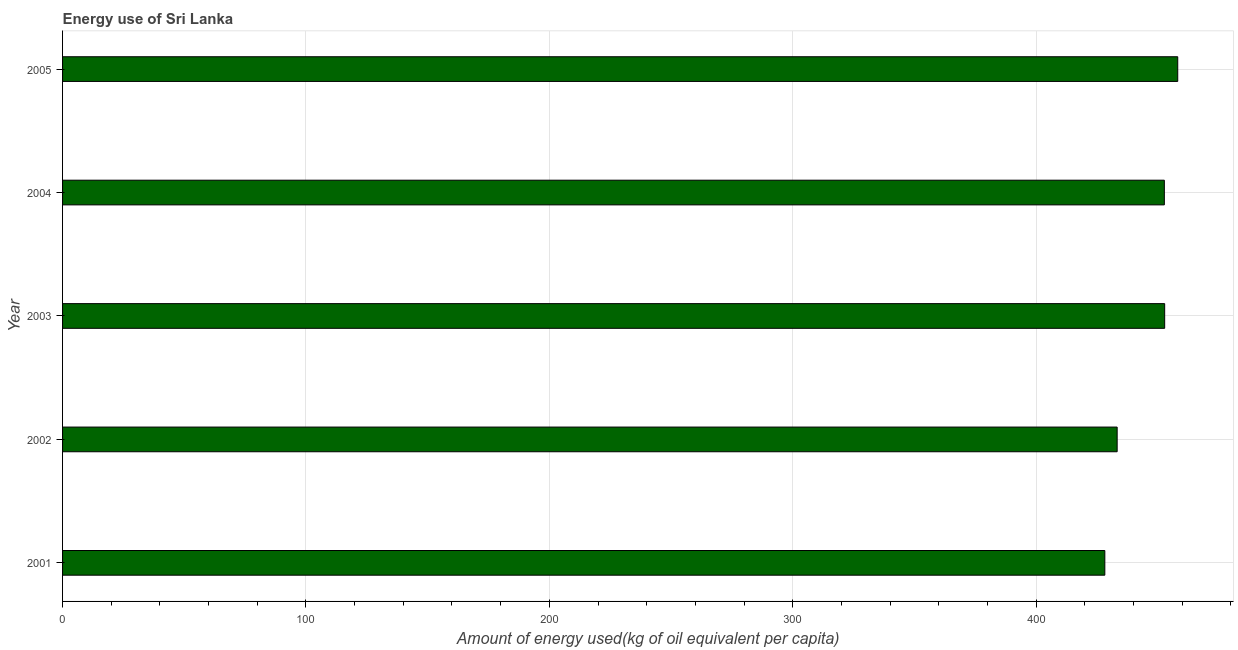What is the title of the graph?
Give a very brief answer. Energy use of Sri Lanka. What is the label or title of the X-axis?
Ensure brevity in your answer.  Amount of energy used(kg of oil equivalent per capita). What is the label or title of the Y-axis?
Offer a very short reply. Year. What is the amount of energy used in 2001?
Keep it short and to the point. 428.23. Across all years, what is the maximum amount of energy used?
Offer a terse response. 458.19. Across all years, what is the minimum amount of energy used?
Provide a succinct answer. 428.23. In which year was the amount of energy used maximum?
Provide a succinct answer. 2005. In which year was the amount of energy used minimum?
Provide a short and direct response. 2001. What is the sum of the amount of energy used?
Your answer should be very brief. 2225.23. What is the difference between the amount of energy used in 2001 and 2005?
Your answer should be very brief. -29.96. What is the average amount of energy used per year?
Provide a succinct answer. 445.05. What is the median amount of energy used?
Make the answer very short. 452.69. In how many years, is the amount of energy used greater than 240 kg?
Make the answer very short. 5. Do a majority of the years between 2001 and 2005 (inclusive) have amount of energy used greater than 100 kg?
Make the answer very short. Yes. What is the ratio of the amount of energy used in 2004 to that in 2005?
Your answer should be compact. 0.99. Is the amount of energy used in 2003 less than that in 2004?
Offer a terse response. No. Is the difference between the amount of energy used in 2002 and 2003 greater than the difference between any two years?
Provide a short and direct response. No. What is the difference between the highest and the second highest amount of energy used?
Give a very brief answer. 5.37. Is the sum of the amount of energy used in 2002 and 2005 greater than the maximum amount of energy used across all years?
Provide a short and direct response. Yes. What is the difference between the highest and the lowest amount of energy used?
Make the answer very short. 29.96. In how many years, is the amount of energy used greater than the average amount of energy used taken over all years?
Provide a short and direct response. 3. What is the Amount of energy used(kg of oil equivalent per capita) of 2001?
Offer a very short reply. 428.23. What is the Amount of energy used(kg of oil equivalent per capita) of 2002?
Offer a very short reply. 433.3. What is the Amount of energy used(kg of oil equivalent per capita) in 2003?
Make the answer very short. 452.82. What is the Amount of energy used(kg of oil equivalent per capita) in 2004?
Provide a short and direct response. 452.69. What is the Amount of energy used(kg of oil equivalent per capita) in 2005?
Your response must be concise. 458.19. What is the difference between the Amount of energy used(kg of oil equivalent per capita) in 2001 and 2002?
Give a very brief answer. -5.07. What is the difference between the Amount of energy used(kg of oil equivalent per capita) in 2001 and 2003?
Your answer should be very brief. -24.59. What is the difference between the Amount of energy used(kg of oil equivalent per capita) in 2001 and 2004?
Give a very brief answer. -24.46. What is the difference between the Amount of energy used(kg of oil equivalent per capita) in 2001 and 2005?
Offer a very short reply. -29.96. What is the difference between the Amount of energy used(kg of oil equivalent per capita) in 2002 and 2003?
Keep it short and to the point. -19.52. What is the difference between the Amount of energy used(kg of oil equivalent per capita) in 2002 and 2004?
Your answer should be compact. -19.39. What is the difference between the Amount of energy used(kg of oil equivalent per capita) in 2002 and 2005?
Provide a short and direct response. -24.89. What is the difference between the Amount of energy used(kg of oil equivalent per capita) in 2003 and 2004?
Provide a succinct answer. 0.13. What is the difference between the Amount of energy used(kg of oil equivalent per capita) in 2003 and 2005?
Offer a terse response. -5.37. What is the difference between the Amount of energy used(kg of oil equivalent per capita) in 2004 and 2005?
Offer a terse response. -5.5. What is the ratio of the Amount of energy used(kg of oil equivalent per capita) in 2001 to that in 2002?
Your response must be concise. 0.99. What is the ratio of the Amount of energy used(kg of oil equivalent per capita) in 2001 to that in 2003?
Offer a terse response. 0.95. What is the ratio of the Amount of energy used(kg of oil equivalent per capita) in 2001 to that in 2004?
Offer a very short reply. 0.95. What is the ratio of the Amount of energy used(kg of oil equivalent per capita) in 2001 to that in 2005?
Your answer should be very brief. 0.94. What is the ratio of the Amount of energy used(kg of oil equivalent per capita) in 2002 to that in 2005?
Your answer should be compact. 0.95. 